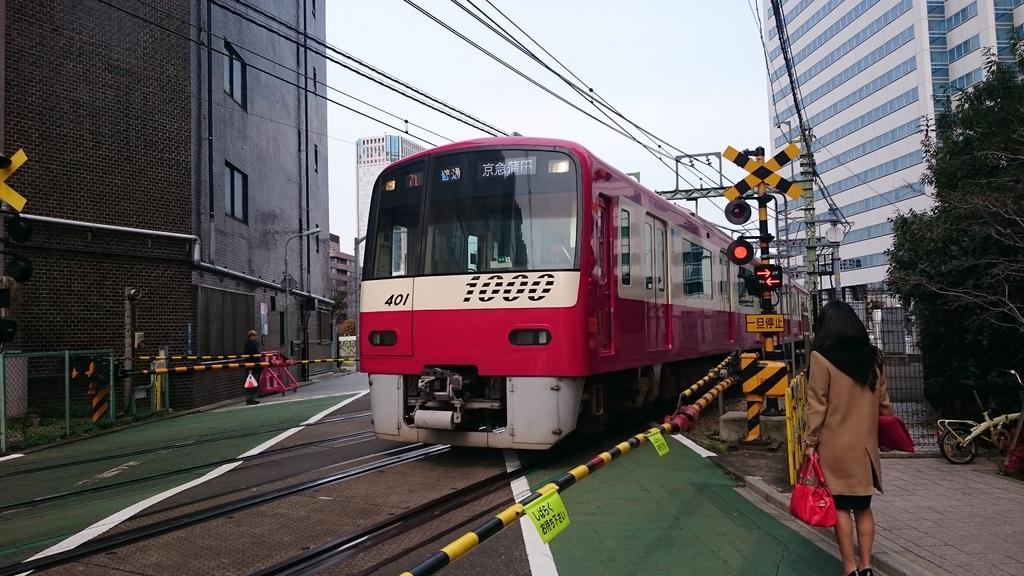Describe this image in one or two sentences. In the picture I can see the train on the track. I can see a woman standing on the side of the railway track and she is carrying a bag. There is a bicycle on the side of the railway track. I can see the signal pole on the right side. There are buildings on the left side and the right side. I can see the barricade poles in the picture. There are trees on the right side. 